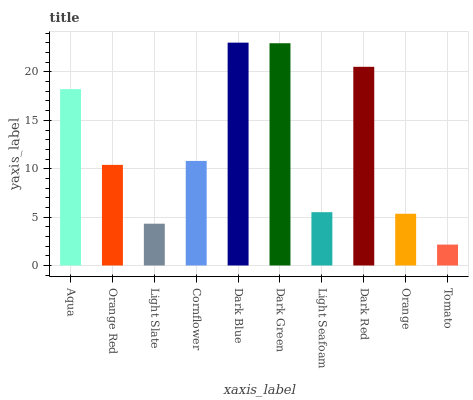Is Tomato the minimum?
Answer yes or no. Yes. Is Dark Blue the maximum?
Answer yes or no. Yes. Is Orange Red the minimum?
Answer yes or no. No. Is Orange Red the maximum?
Answer yes or no. No. Is Aqua greater than Orange Red?
Answer yes or no. Yes. Is Orange Red less than Aqua?
Answer yes or no. Yes. Is Orange Red greater than Aqua?
Answer yes or no. No. Is Aqua less than Orange Red?
Answer yes or no. No. Is Cornflower the high median?
Answer yes or no. Yes. Is Orange Red the low median?
Answer yes or no. Yes. Is Dark Blue the high median?
Answer yes or no. No. Is Light Seafoam the low median?
Answer yes or no. No. 